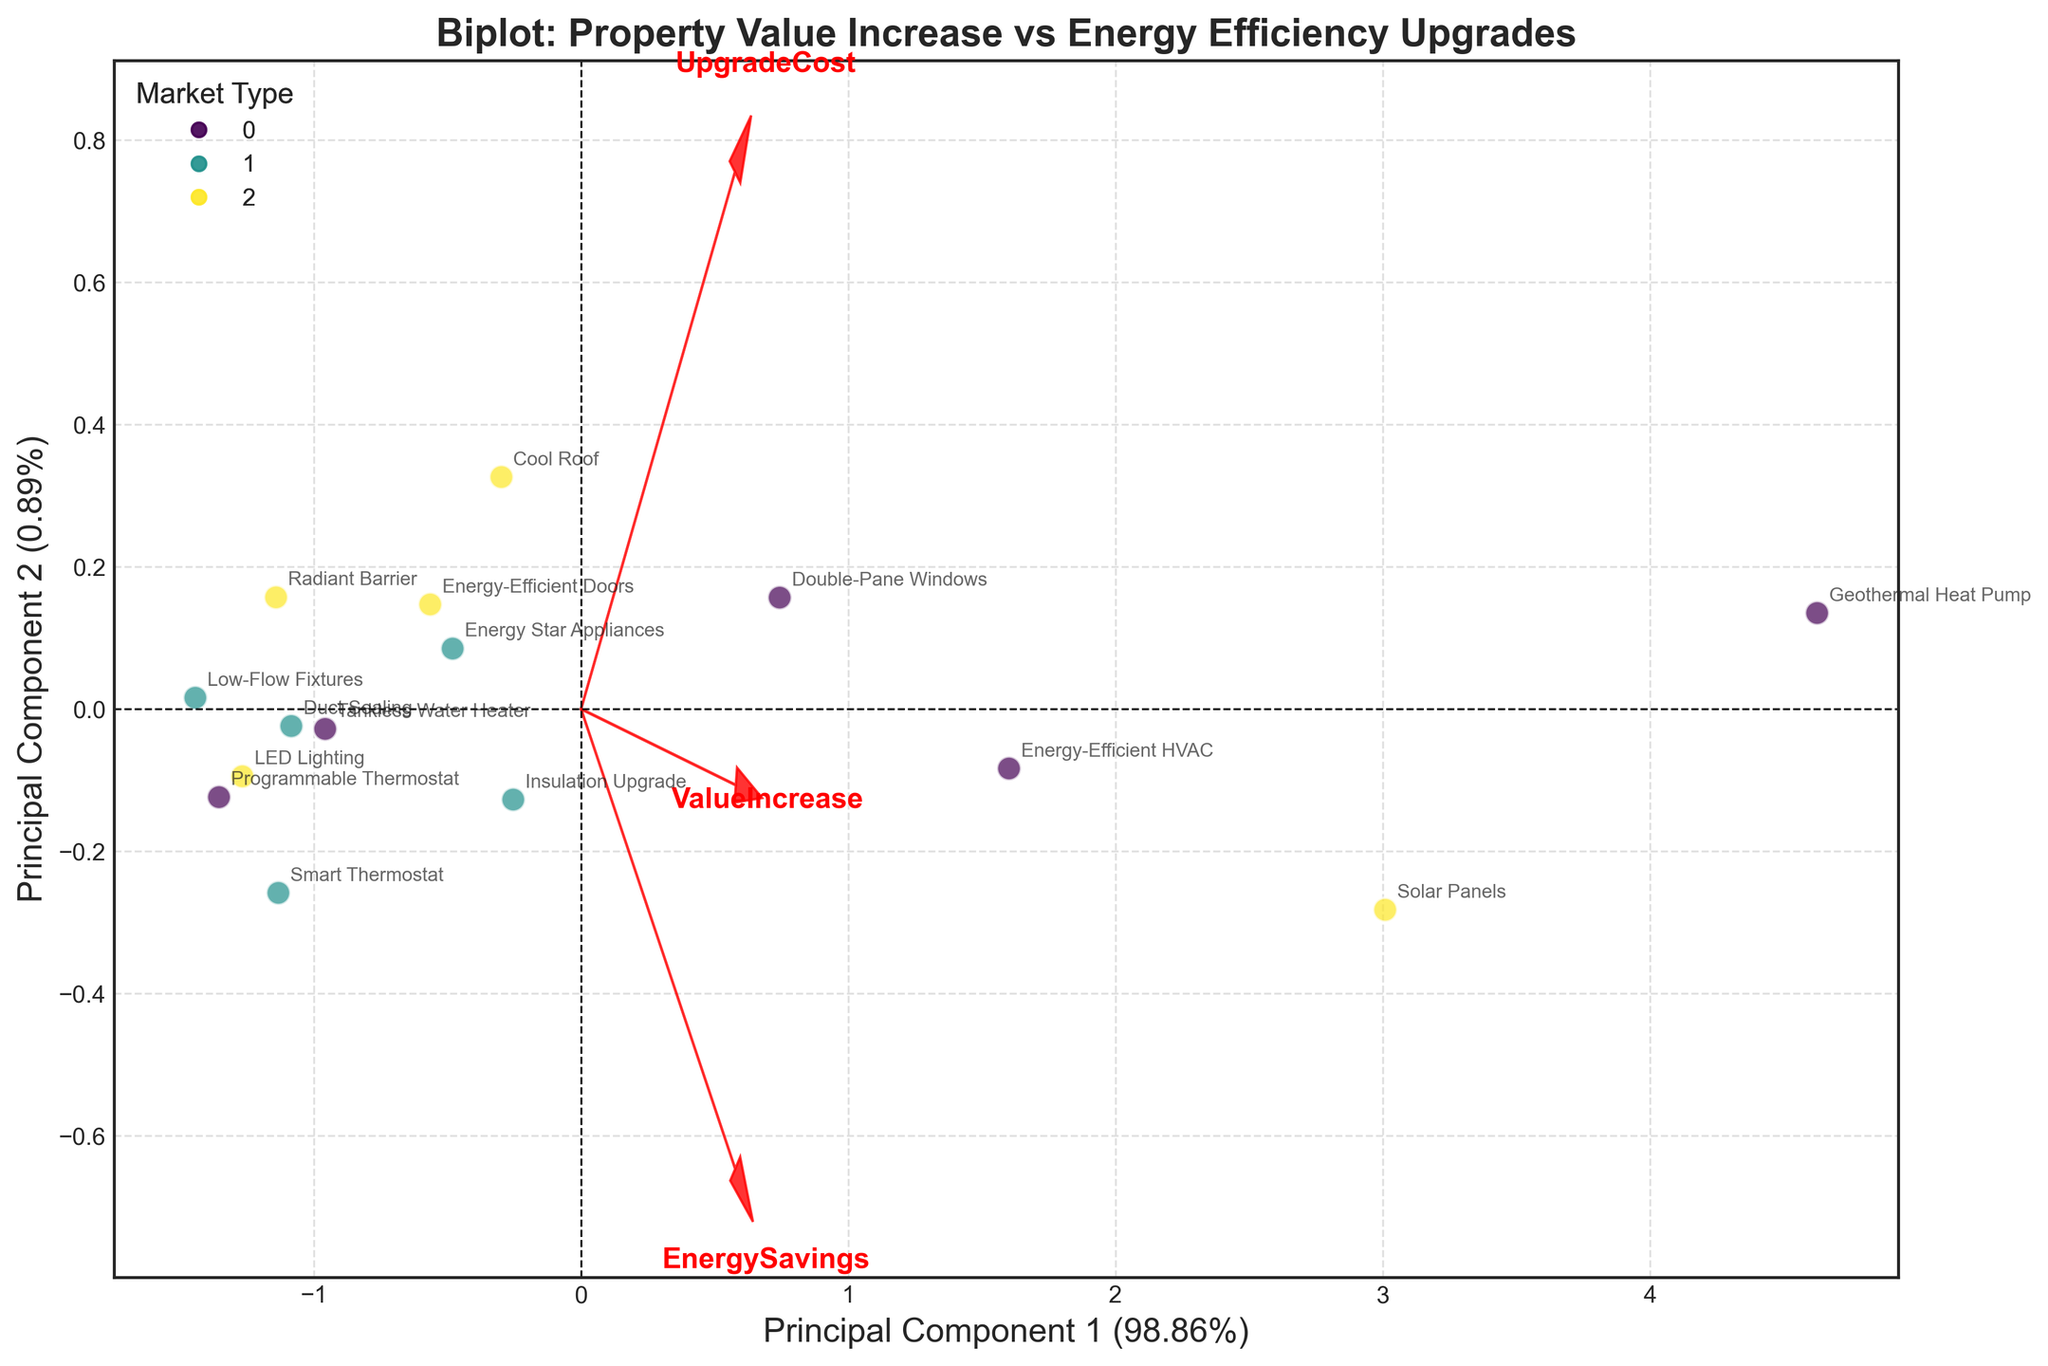What is the title of the plot? The title is found at the top of the figure. It describes the content of the plot succinctly.
Answer: Biplot: Property Value Increase vs Energy Efficiency Upgrades How many principal components are shown in the biplot? From the axis labels, we see two components, Principal Component 1 (PC1) and Principal Component 2 (PC2).
Answer: Two Which energy-efficient upgrade results in the highest property value increase? By looking at the annotation labels and their position in the plot, Geothermal Heat Pump stands farthest along the x-axis, indicating a high-value increase.
Answer: Geothermal Heat Pump What feature vector is closest to the x-axis? Feature vectors are represented by red arrows, with one arrow pointing closest to the x-axis. The arrow for "ValueIncrease" is closest based on its direction.
Answer: ValueIncrease Which market types are represented in the plot? Market types (Urban, Suburban, Rural) can be identified from the legend in the upper left corner.
Answer: Urban, Suburban, Rural What percentage of the variation is explained by Principal Component 1? This percentage is found in the x-axis label within the parentheses, after "Principal Component 1".
Answer: Approximately 61.22% Which property is located near the origin of the biplot? The property near (0,0) on the biplot can be identified by locating the annotation closest to the center.
Answer: LED Lighting Are properties with high upgrade costs generally located on the left or right side of the biplot? Upgrade Cost is represented by a feature vector. Its direction suggests properties with higher upgrade costs lie to the right.
Answer: Right side How does the Smart Thermostat compare to the Insulation Upgrade in terms of location on the biplot? By comparing the positions of these two property labels, the Smart Thermostat is closer to the lower left quadrant, while the Insulation Upgrade is higher on the y-axis.
Answer: Smart Thermostat is lower and more to the left Which principal component explains more variance? Compare the percentages explained by PC1 and PC2, as noted in their respective axis labels.
Answer: Principal Component 1 